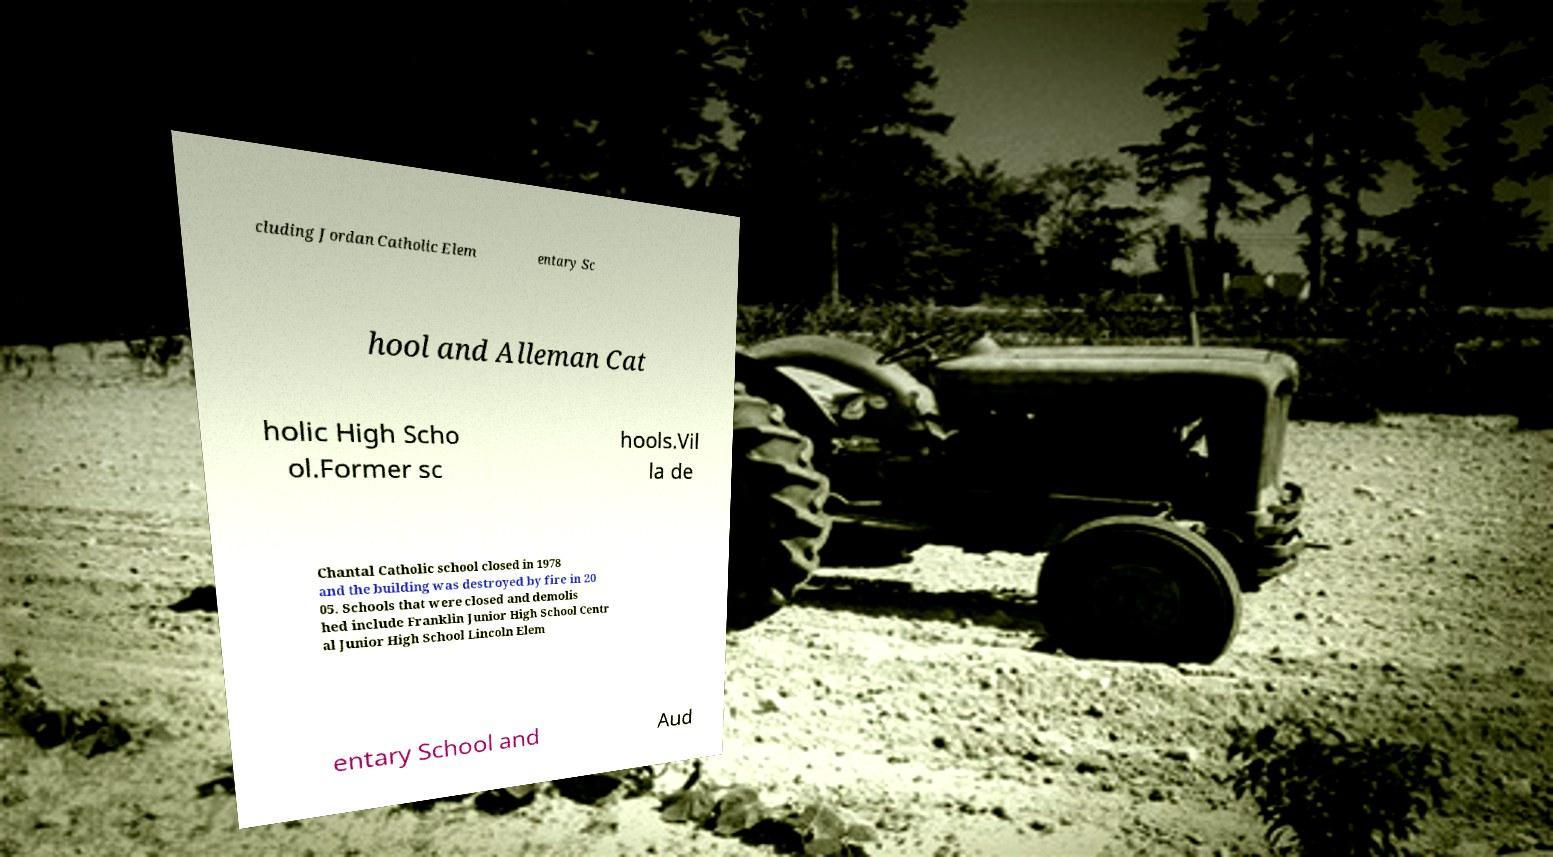Could you assist in decoding the text presented in this image and type it out clearly? cluding Jordan Catholic Elem entary Sc hool and Alleman Cat holic High Scho ol.Former sc hools.Vil la de Chantal Catholic school closed in 1978 and the building was destroyed by fire in 20 05. Schools that were closed and demolis hed include Franklin Junior High School Centr al Junior High School Lincoln Elem entary School and Aud 